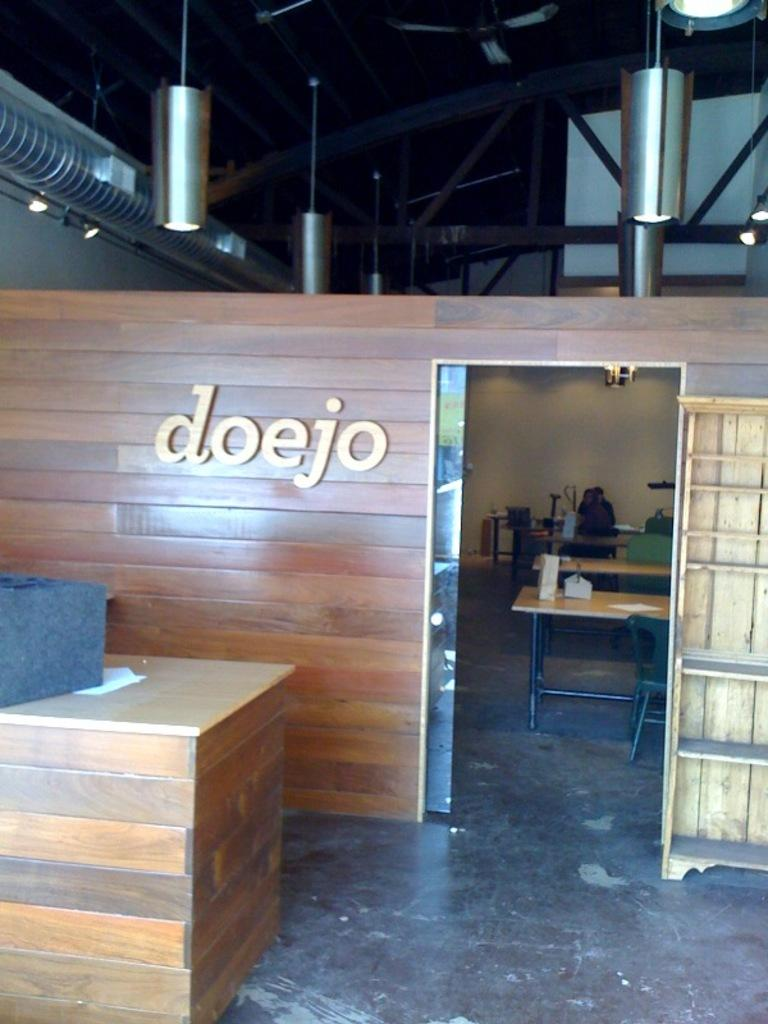<image>
Describe the image concisely. Store front with the word "doejo" on a wooden wall. 